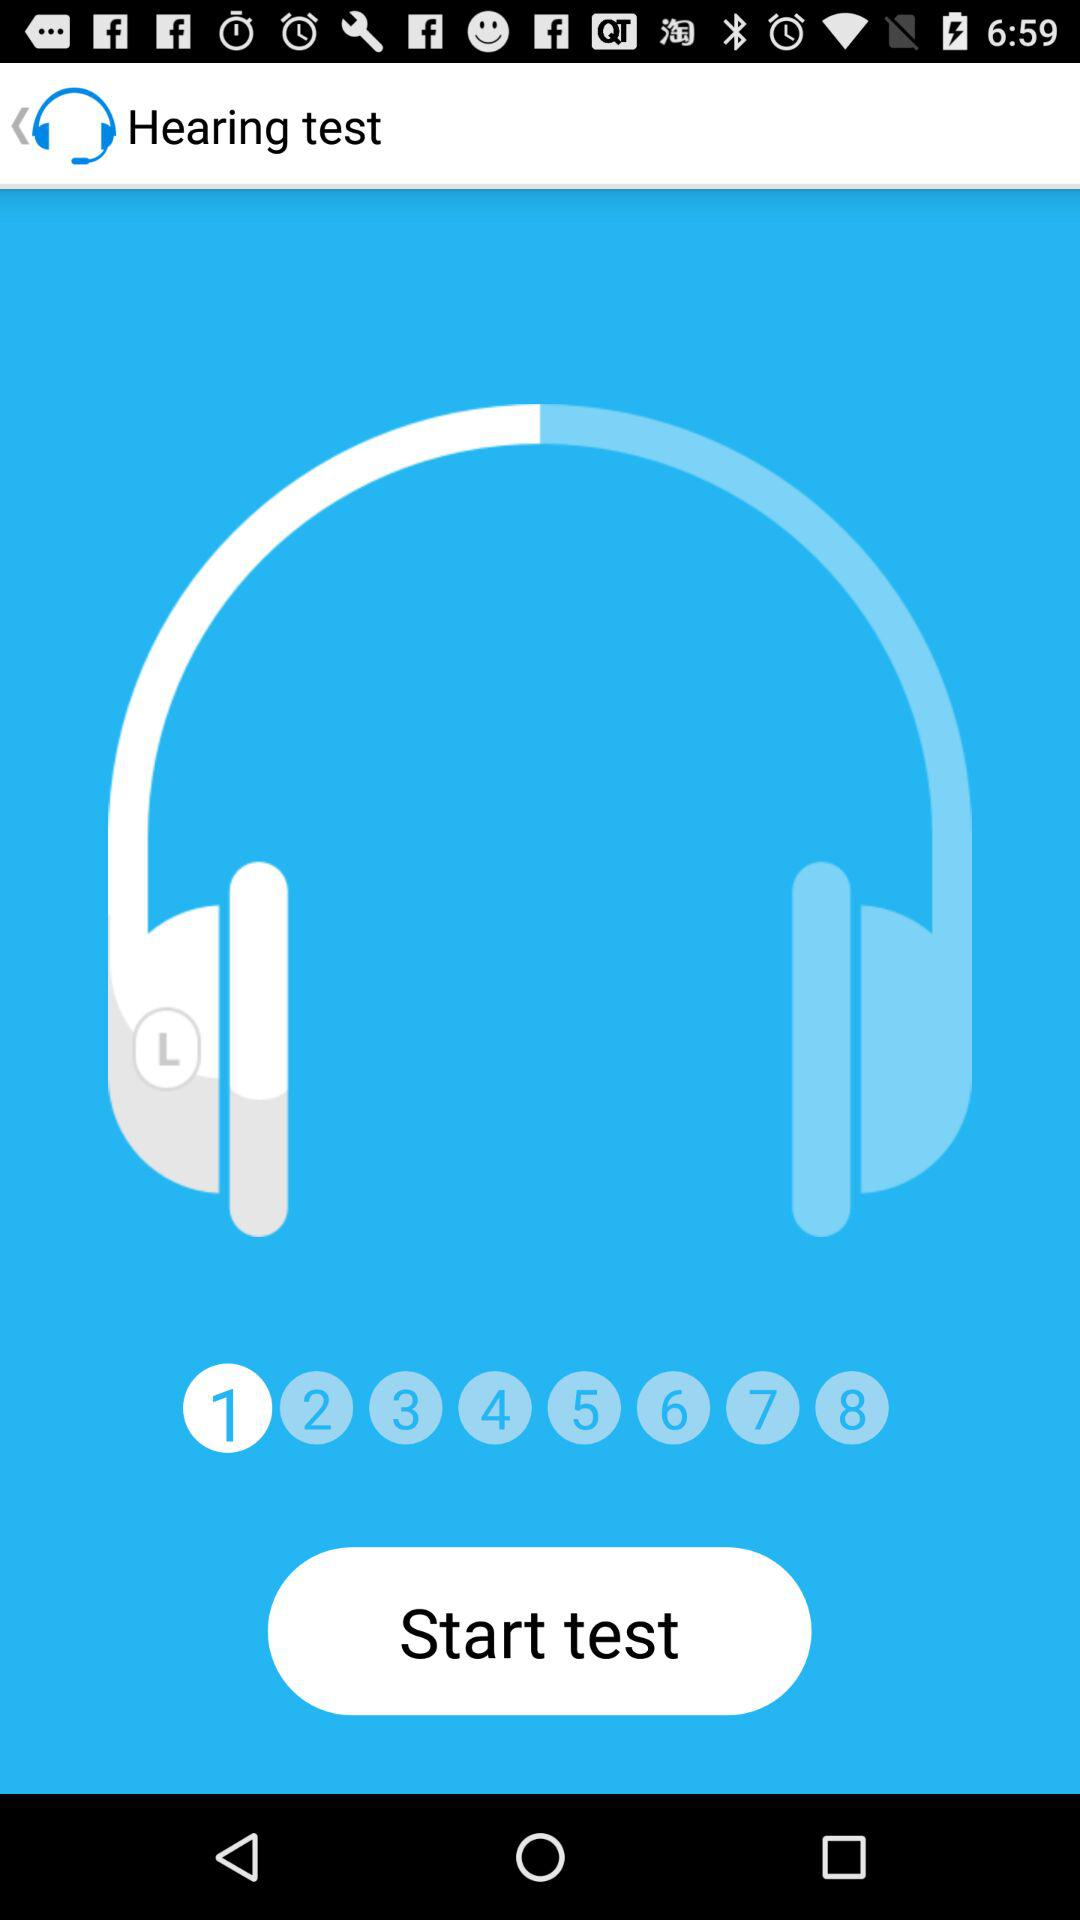How many numbers are on the screen?
Answer the question using a single word or phrase. 8 